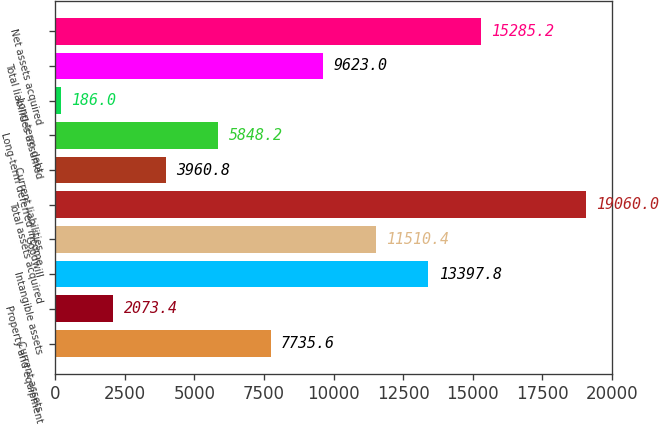Convert chart. <chart><loc_0><loc_0><loc_500><loc_500><bar_chart><fcel>Current assets<fcel>Property and equipment<fcel>Intangible assets<fcel>Goodwill<fcel>Total assets acquired<fcel>Current liabilities<fcel>Long-term deferred income<fcel>Long-term debt<fcel>Total liabilities assumed<fcel>Net assets acquired<nl><fcel>7735.6<fcel>2073.4<fcel>13397.8<fcel>11510.4<fcel>19060<fcel>3960.8<fcel>5848.2<fcel>186<fcel>9623<fcel>15285.2<nl></chart> 